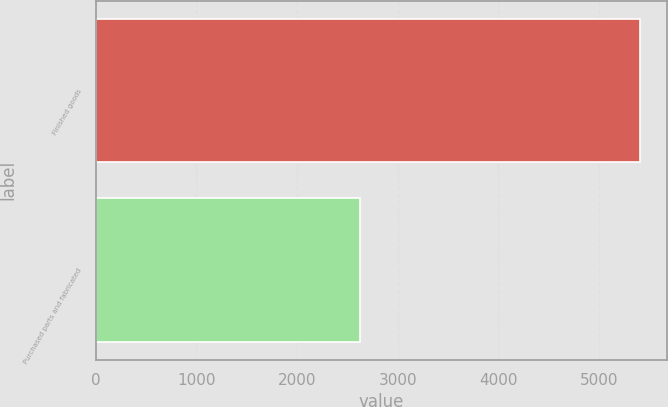Convert chart to OTSL. <chart><loc_0><loc_0><loc_500><loc_500><bar_chart><fcel>Finished goods<fcel>Purchased parts and fabricated<nl><fcel>5404<fcel>2629<nl></chart> 